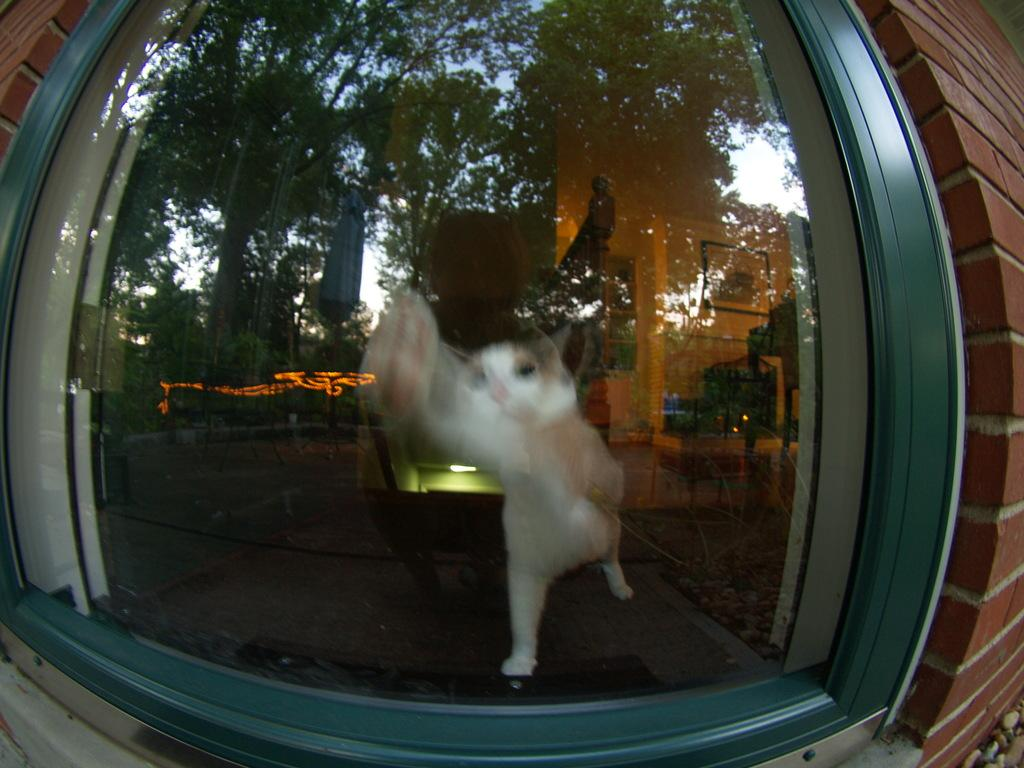What is one of the objects present in the image? There is a glass in the image. What type of structure can be seen in the image? There is a brick wall in the image. What type of animal is in the image? There is a cat in the image. What type of vegetation is in the image? There are trees in the image. What part of the natural environment is visible in the image? The sky is visible in the image. What type of man-made structure is in the image? There is a building in the image. What is hanging on the wall in the image? There is a frame on the wall in the image. What type of comb is being used by the cat in the image? There is no comb present in the image, and the cat is not using any comb. What type of scene is being depicted in the image? The image does not depict a specific scene; it is a collection of objects and structures. 